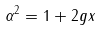Convert formula to latex. <formula><loc_0><loc_0><loc_500><loc_500>\alpha ^ { 2 } = 1 + 2 g x</formula> 